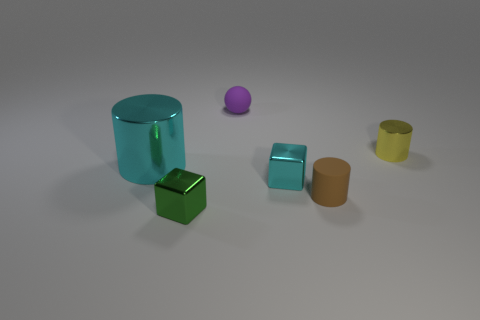Is there anything else that is the same size as the cyan metal cylinder?
Your answer should be very brief. No. How many rubber cylinders have the same size as the cyan metal cylinder?
Provide a succinct answer. 0. How many shiny objects are tiny balls or large cylinders?
Keep it short and to the point. 1. The shiny cube that is the same color as the large thing is what size?
Give a very brief answer. Small. What is the material of the cyan object on the left side of the block in front of the small cyan metal cube?
Provide a succinct answer. Metal. What number of objects are small yellow shiny cylinders or things left of the purple object?
Your response must be concise. 3. There is a purple sphere that is the same material as the brown object; what is its size?
Keep it short and to the point. Small. How many green objects are either large metallic objects or large blocks?
Offer a very short reply. 0. There is a small metal object that is the same color as the large shiny cylinder; what is its shape?
Make the answer very short. Cube. Is there anything else that is the same material as the sphere?
Keep it short and to the point. Yes. 